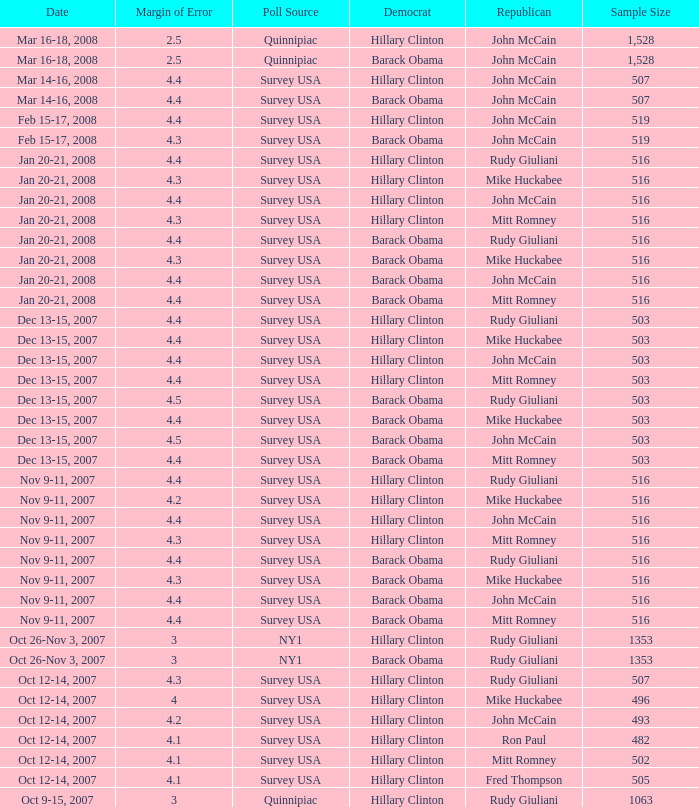Which Democrat was selected in the poll with a sample size smaller than 516 where the Republican chosen was Ron Paul? Hillary Clinton. 